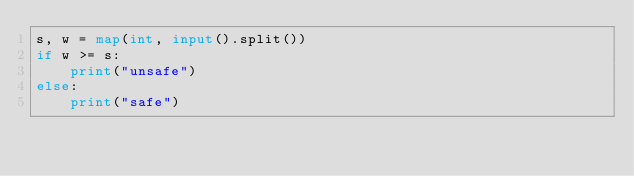Convert code to text. <code><loc_0><loc_0><loc_500><loc_500><_Python_>s, w = map(int, input().split())
if w >= s:
    print("unsafe")
else:
    print("safe")</code> 